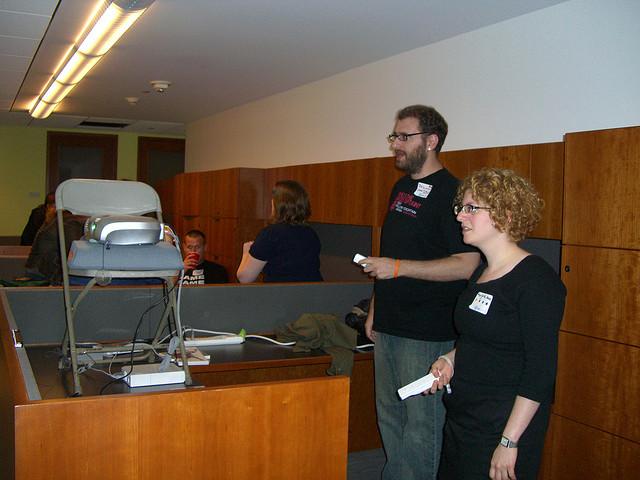Are they going to shoot something?
Answer briefly. No. Do the name tags on these people also function as jewelry?
Short answer required. No. Is there anyone else in the kitchen with the man?
Concise answer only. Yes. What color is the woman wearing?
Write a very short answer. Black. 